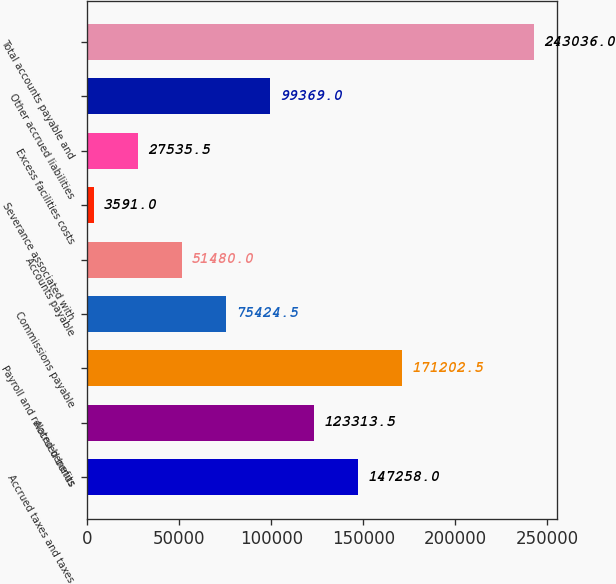<chart> <loc_0><loc_0><loc_500><loc_500><bar_chart><fcel>Accrued taxes and taxes<fcel>Accrued bonus<fcel>Payroll and related benefits<fcel>Commissions payable<fcel>Accounts payable<fcel>Severance associated with<fcel>Excess facilities costs<fcel>Other accrued liabilities<fcel>Total accounts payable and<nl><fcel>147258<fcel>123314<fcel>171202<fcel>75424.5<fcel>51480<fcel>3591<fcel>27535.5<fcel>99369<fcel>243036<nl></chart> 